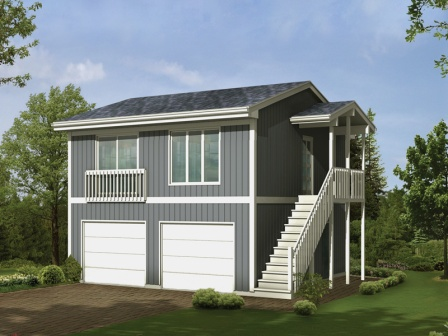Can you tell me more about the architectural style of the house? The house showcases a blend of modern and traditional architectural elements. The use of gray and white tones provides a sleek and contemporary appearance, while the covered porch and symmetric structure add a touch of classic charm. The white trim and railings contribute to a clean, polished look, and the large windows invite ample natural light, enhancing the overall aesthetics. What kind of landscaping would complement this house? To magnify the house's serene and welcoming ambiance, consider incorporating a mix of lush green lawns, flowering shrubs, and small trees. Adding a variety of perennials and seasonal flowers can brighten up the exterior, while strategically placed evergreens can provide year-round structure. Pathways lined with well-maintained hedges or decorative grasses would further enhance the picturesque setting. 